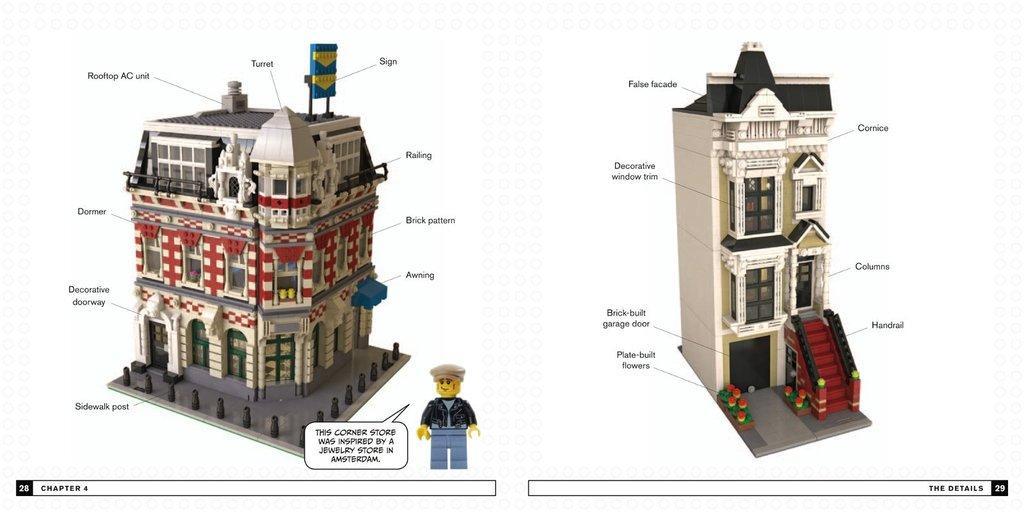Please provide a concise description of this image. This is an animated image, in this image there are two buildings, there are doors, there are windows, there is a staircase, there is a man, there is text, the background of the image is white in color. 